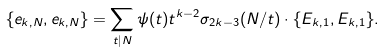<formula> <loc_0><loc_0><loc_500><loc_500>\{ e _ { k , N } , e _ { k , N } \} = \sum _ { t | N } \psi ( t ) t ^ { k - 2 } \sigma _ { 2 k - 3 } ( N / t ) \cdot \{ E _ { k , 1 } , E _ { k , 1 } \} .</formula> 